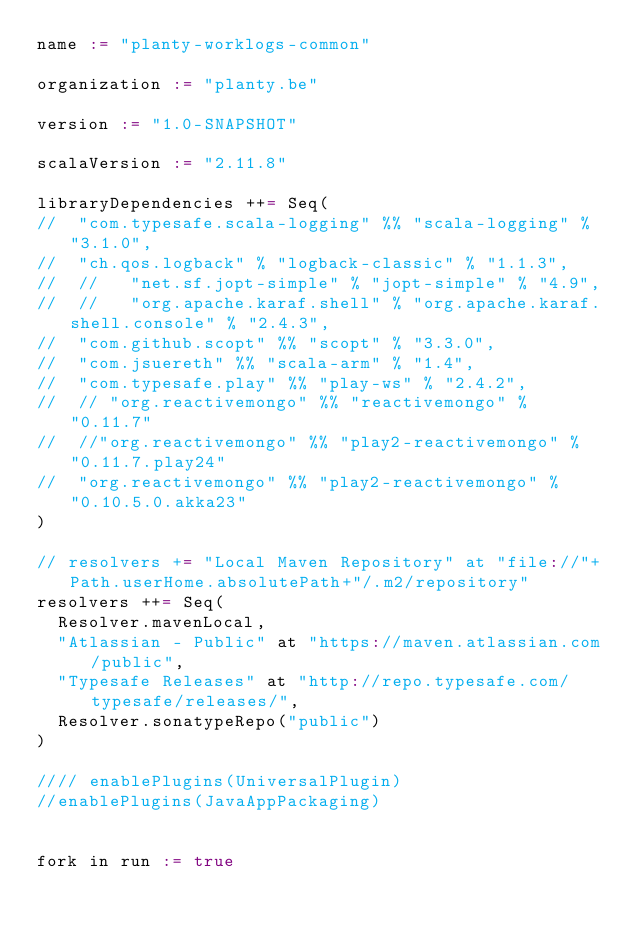Convert code to text. <code><loc_0><loc_0><loc_500><loc_500><_Scala_>name := "planty-worklogs-common"

organization := "planty.be"

version := "1.0-SNAPSHOT"

scalaVersion := "2.11.8"

libraryDependencies ++= Seq(
//  "com.typesafe.scala-logging" %% "scala-logging" % "3.1.0",
//  "ch.qos.logback" % "logback-classic" % "1.1.3",
//  //   "net.sf.jopt-simple" % "jopt-simple" % "4.9",
//  //   "org.apache.karaf.shell" % "org.apache.karaf.shell.console" % "2.4.3",
//  "com.github.scopt" %% "scopt" % "3.3.0",
//  "com.jsuereth" %% "scala-arm" % "1.4",
//  "com.typesafe.play" %% "play-ws" % "2.4.2",
//  // "org.reactivemongo" %% "reactivemongo" % "0.11.7"
//  //"org.reactivemongo" %% "play2-reactivemongo" % "0.11.7.play24"
//  "org.reactivemongo" %% "play2-reactivemongo" % "0.10.5.0.akka23"
)

// resolvers += "Local Maven Repository" at "file://"+Path.userHome.absolutePath+"/.m2/repository"
resolvers ++= Seq(
  Resolver.mavenLocal,
  "Atlassian - Public" at "https://maven.atlassian.com/public",
  "Typesafe Releases" at "http://repo.typesafe.com/typesafe/releases/",
  Resolver.sonatypeRepo("public")
)

//// enablePlugins(UniversalPlugin)
//enablePlugins(JavaAppPackaging)


fork in run := true
</code> 